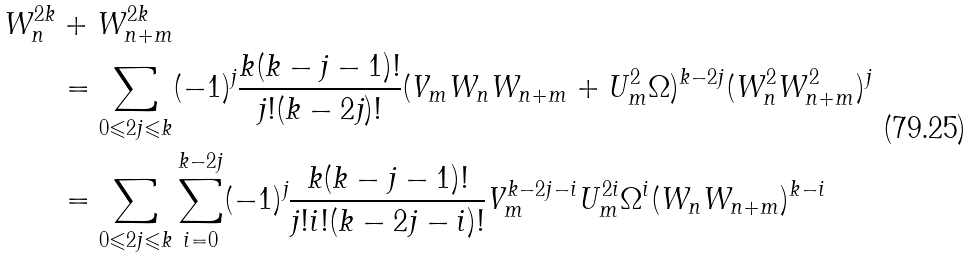<formula> <loc_0><loc_0><loc_500><loc_500>W _ { n } ^ { 2 k } & + W _ { n + m } ^ { 2 k } \\ & = \sum _ { 0 \leqslant 2 j \leqslant k } ( - 1 ) ^ { j } \frac { k ( k - j - 1 ) ! } { j ! ( k - 2 j ) ! } ( V _ { m } W _ { n } W _ { n + m } + U _ { m } ^ { 2 } \Omega ) ^ { k - 2 j } ( W _ { n } ^ { 2 } W _ { n + m } ^ { 2 } ) ^ { j } \\ & = \sum _ { 0 \leqslant 2 j \leqslant k } \sum _ { i = 0 } ^ { k - 2 j } ( - 1 ) ^ { j } \frac { k ( k - j - 1 ) ! } { j ! i ! ( k - 2 j - i ) ! } V _ { m } ^ { k - 2 j - i } U _ { m } ^ { 2 i } \Omega ^ { i } ( W _ { n } W _ { n + m } ) ^ { k - i }</formula> 